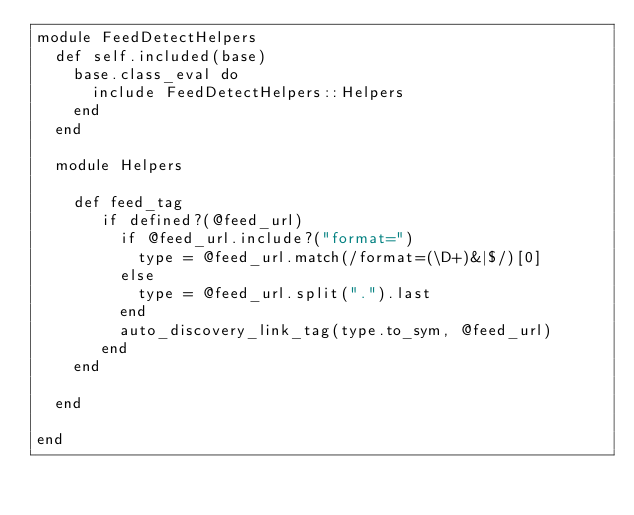<code> <loc_0><loc_0><loc_500><loc_500><_Ruby_>module FeedDetectHelpers
  def self.included(base)
    base.class_eval do
      include FeedDetectHelpers::Helpers
    end
  end
  
  module Helpers
   
    def feed_tag
       if defined?(@feed_url)
         if @feed_url.include?("format=")
           type = @feed_url.match(/format=(\D+)&|$/)[0]
         else 
           type = @feed_url.split(".").last
         end
         auto_discovery_link_tag(type.to_sym, @feed_url)
       end
    end  
  
  end
  
end</code> 